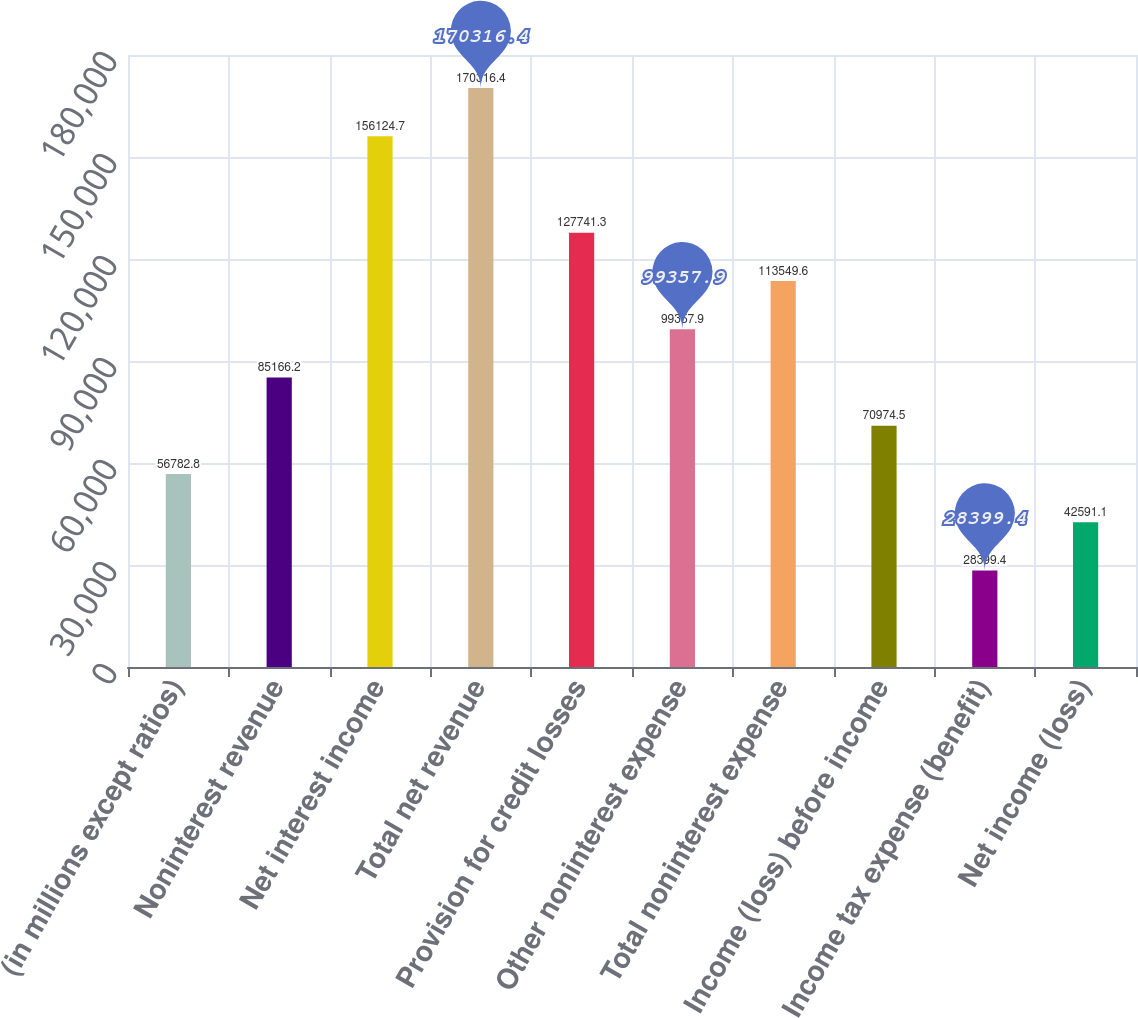<chart> <loc_0><loc_0><loc_500><loc_500><bar_chart><fcel>(in millions except ratios)<fcel>Noninterest revenue<fcel>Net interest income<fcel>Total net revenue<fcel>Provision for credit losses<fcel>Other noninterest expense<fcel>Total noninterest expense<fcel>Income (loss) before income<fcel>Income tax expense (benefit)<fcel>Net income (loss)<nl><fcel>56782.8<fcel>85166.2<fcel>156125<fcel>170316<fcel>127741<fcel>99357.9<fcel>113550<fcel>70974.5<fcel>28399.4<fcel>42591.1<nl></chart> 